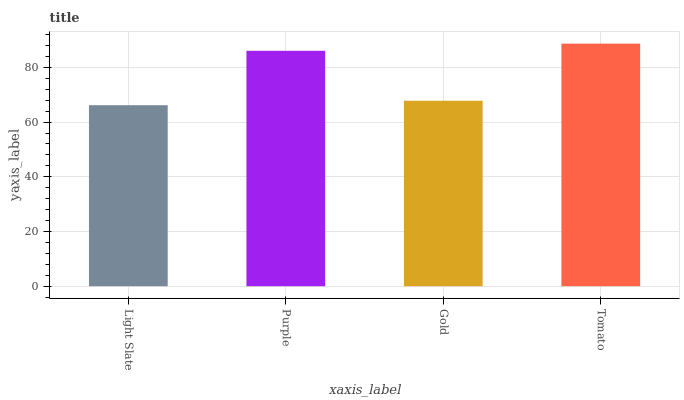Is Light Slate the minimum?
Answer yes or no. Yes. Is Tomato the maximum?
Answer yes or no. Yes. Is Purple the minimum?
Answer yes or no. No. Is Purple the maximum?
Answer yes or no. No. Is Purple greater than Light Slate?
Answer yes or no. Yes. Is Light Slate less than Purple?
Answer yes or no. Yes. Is Light Slate greater than Purple?
Answer yes or no. No. Is Purple less than Light Slate?
Answer yes or no. No. Is Purple the high median?
Answer yes or no. Yes. Is Gold the low median?
Answer yes or no. Yes. Is Gold the high median?
Answer yes or no. No. Is Purple the low median?
Answer yes or no. No. 